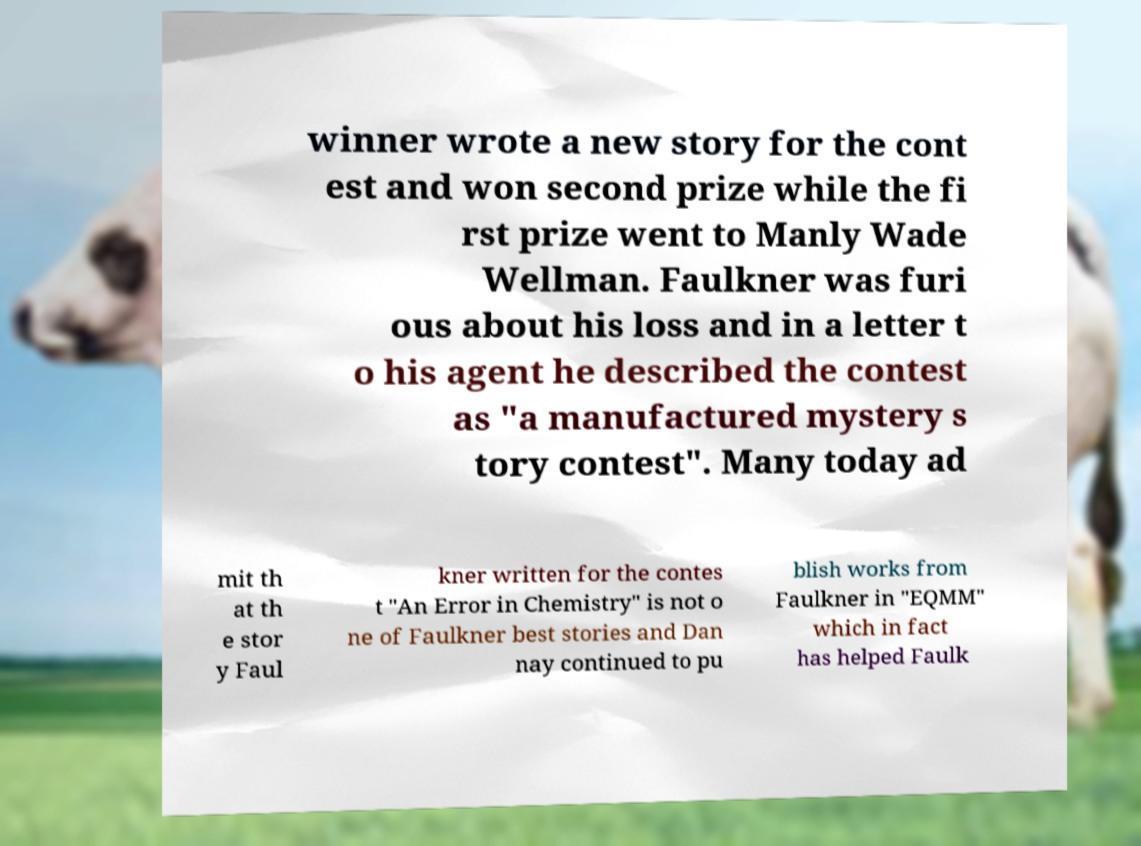What messages or text are displayed in this image? I need them in a readable, typed format. winner wrote a new story for the cont est and won second prize while the fi rst prize went to Manly Wade Wellman. Faulkner was furi ous about his loss and in a letter t o his agent he described the contest as "a manufactured mystery s tory contest". Many today ad mit th at th e stor y Faul kner written for the contes t "An Error in Chemistry" is not o ne of Faulkner best stories and Dan nay continued to pu blish works from Faulkner in "EQMM" which in fact has helped Faulk 